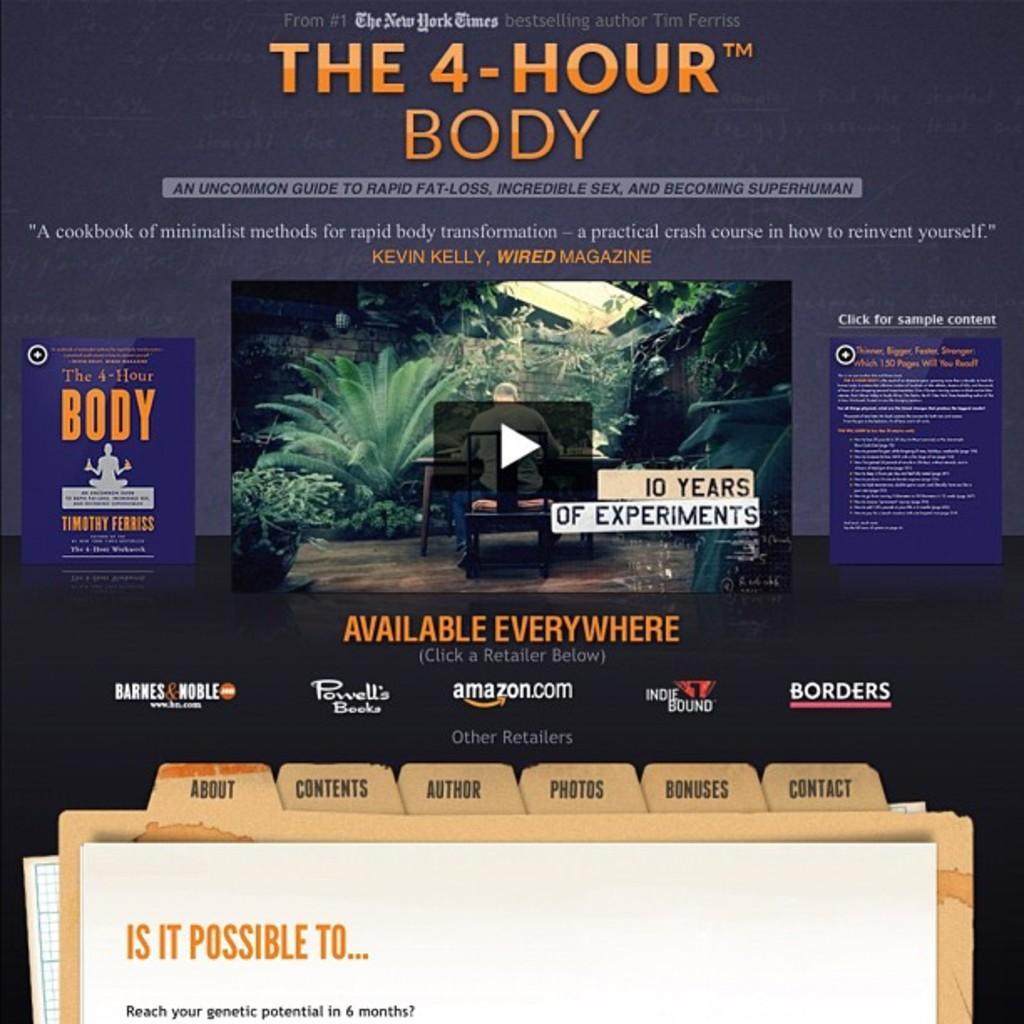Please provide a concise description of this image. In this image I can see a page , in the middle of the page I can see plants and a person sitting on the table and in front of the person I can see a bench and at the top and at the bottom I can see a text. 